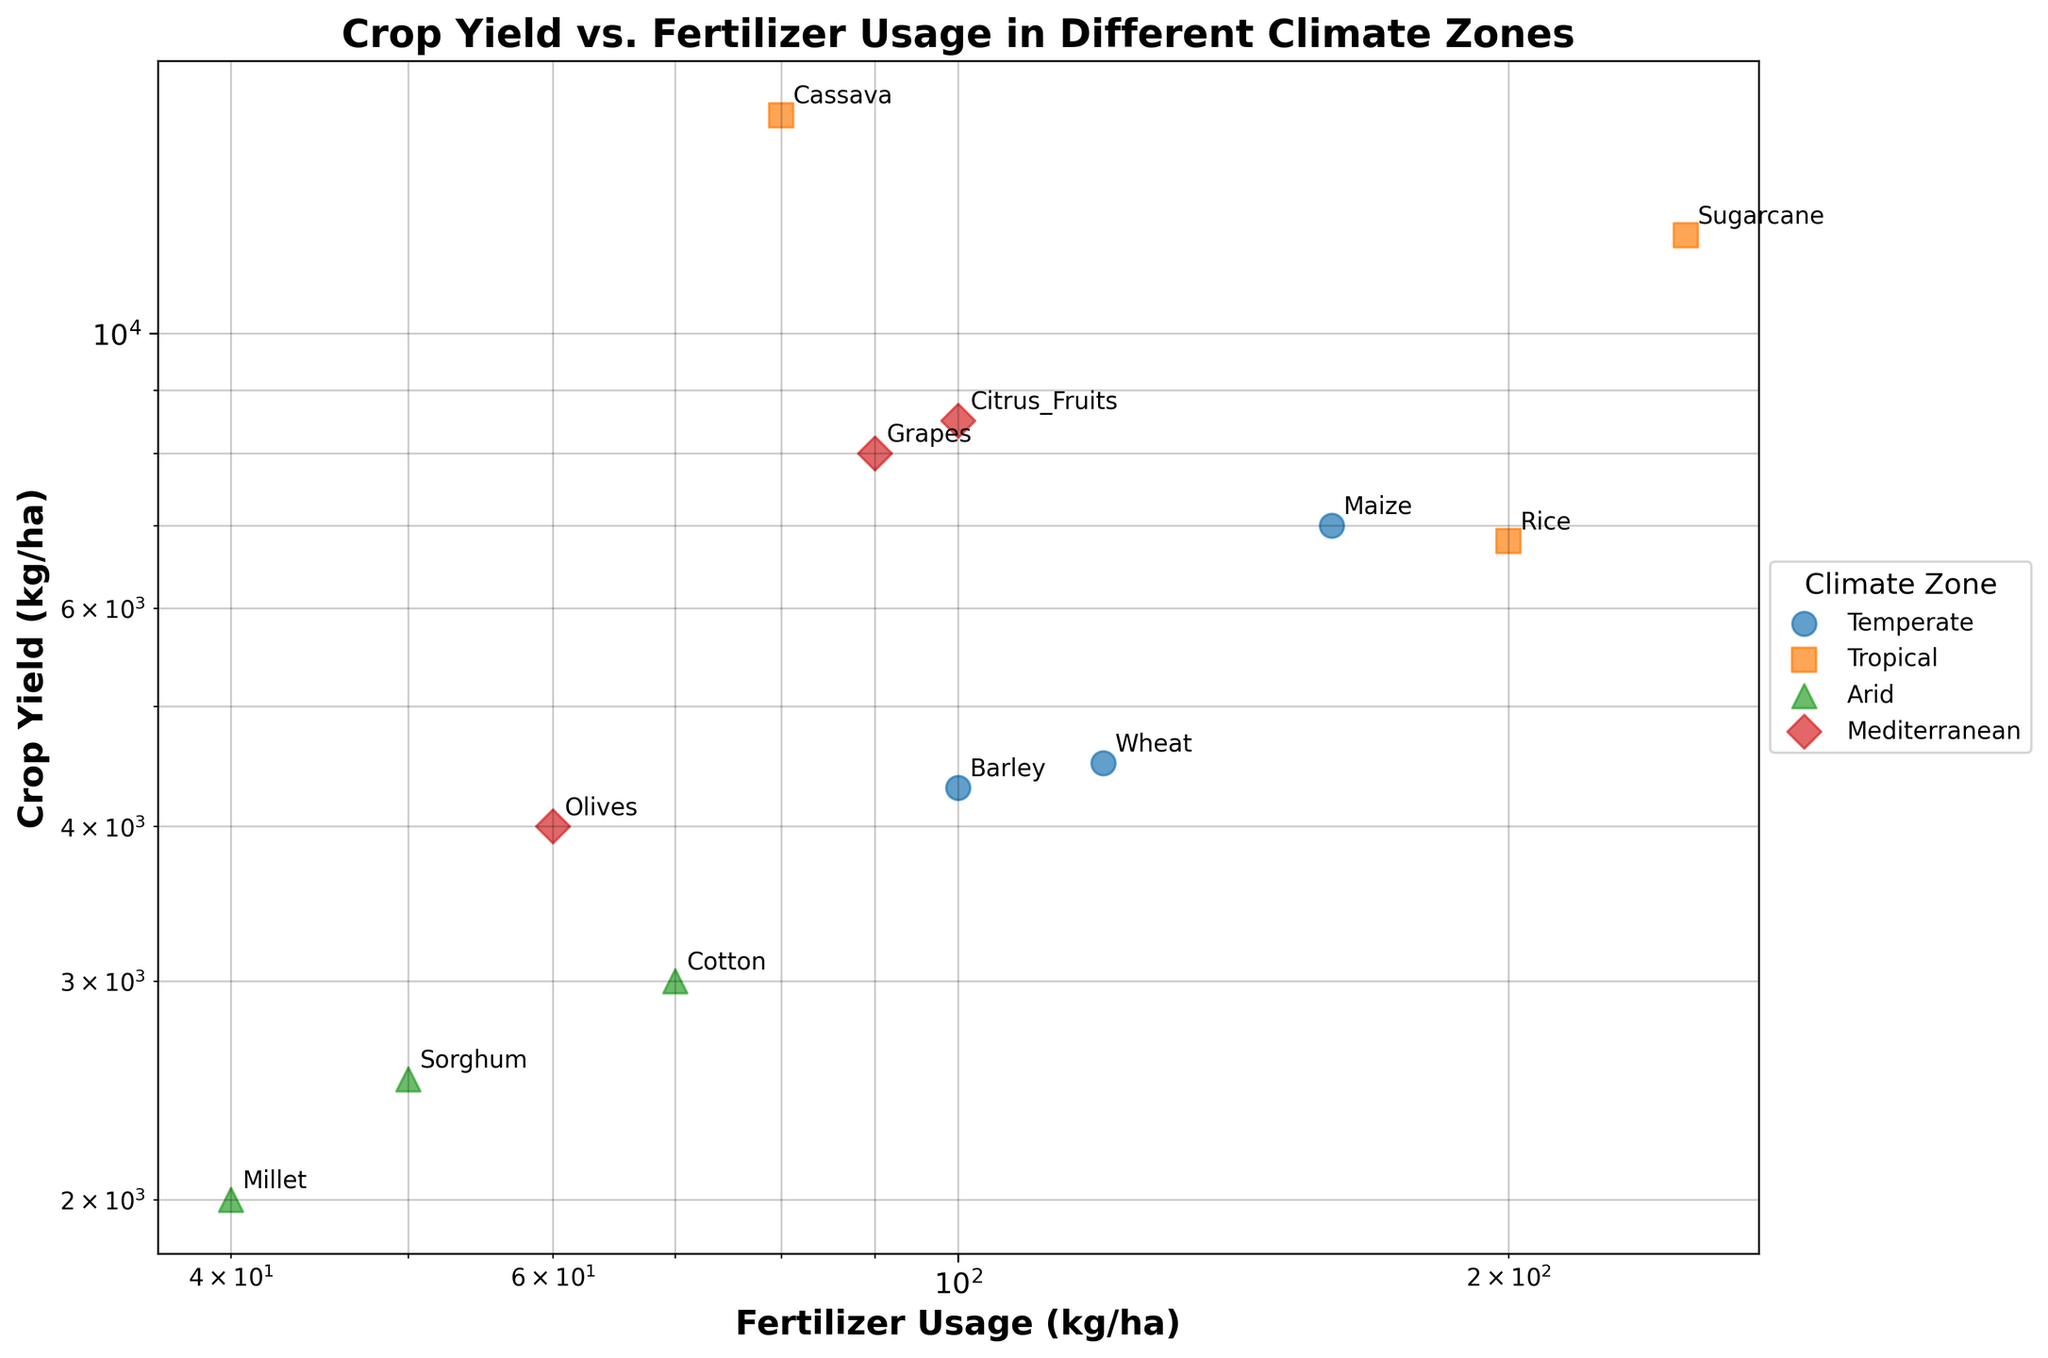What is the title of the figure? The title of the figure is displayed at the top and serves to describe what the scatter plot represents. By reading the title, we can understand that the figure is comparing crop yield and fertilizer usage across different climate zones.
Answer: Crop Yield vs. Fertilizer Usage in Different Climate Zones Which climate zone appears to have the highest crop yield data point? By examining the scatter plot and identifying the points with the highest crop yield, we can determine which climate zone they belong to. The highest crop yield data point will be the point furthest up on the y-axis, where the crop types are labeled.
Answer: Tropical What is the range of fertilizer usage across all climate zones? To find the range of fertilizer usage, we need to identify the smallest and largest values on the x-axis. According to the data, the smallest value is 40 kg/ha and the largest value is 250 kg/ha.
Answer: 40-250 kg/ha Which crop type has the highest yield in the temperate zone, and how much fertilizer does it use? By looking at the points labeled with crop types within the area where the temperate zone data points are plotted, we can find the crop type with the highest yield and its fertilizer usage. The temperate zone includes Wheat, Barley, and Maize. Maize has the highest yield at 7000 kg/ha and uses 160 kg/ha of fertilizer.
Answer: Maize, 160 kg/ha Compare the fertilizer usage for Grapes in the Mediterranean zone and Rice in the Tropical zone. Which uses more fertilizer? By locating the points labeled as Grapes and Rice and examining their positions on the x-axis, we can compare their fertilizer usage values. Grapes (Mediterranean) use 90 kg/ha while Rice (Tropical) uses 200 kg/ha.
Answer: Rice uses more fertilizer What is the approximate yield difference between Sugarcane and Cassava in the Tropical zone? We need to find the points labeled Sugarcane and Cassava in the Tropical zone and subtract their crop yield values. Sugarcane has a yield of 12000 kg/ha, and Cassava has a yield of 15000 kg/ha. The difference is 15000 - 12000 = 3000 kg/ha.
Answer: 3000 kg/ha Which crop type in the Arid zone has the lowest yield and what is its fertilizer usage? By examining the points labeled Sorghum, Millet, and Cotton in the Arid zone, we can identify the one with the lowest position on the y-axis. Millet has the lowest yield at 2000 kg/ha and uses 40 kg/ha of fertilizer.
Answer: Millet, 40 kg/ha What can be said about the relationship between fertilizer usage and crop yield in different climate zones? Observing the scatter plot with log scales, we can see if there is any visible correlation between the two variables across different climate zones. In general, higher fertilizer usage tends to relate to higher crop yield, but this trend varies by climate zone. For example, Cassava in the Tropical zone has a high yield with relatively low fertilizer usage compared to Sugarcane.
Answer: Higher fertilizer generally leads to higher yield, varying by zone 